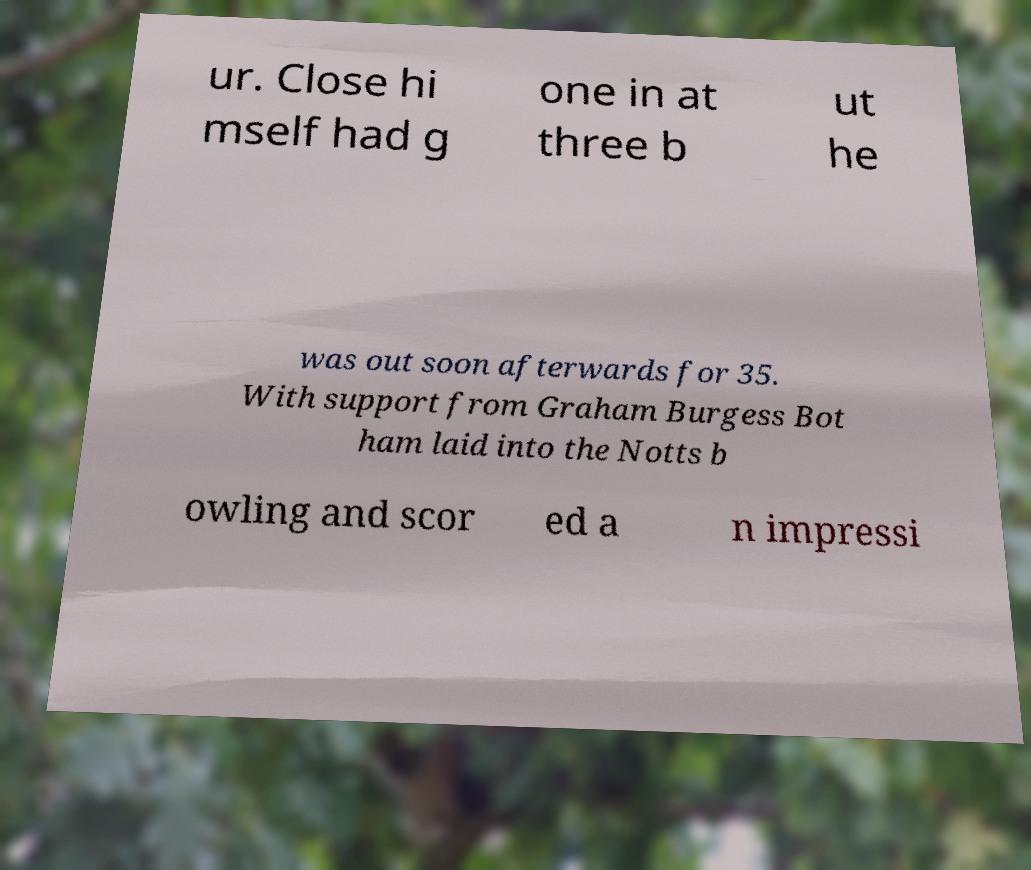Could you extract and type out the text from this image? ur. Close hi mself had g one in at three b ut he was out soon afterwards for 35. With support from Graham Burgess Bot ham laid into the Notts b owling and scor ed a n impressi 